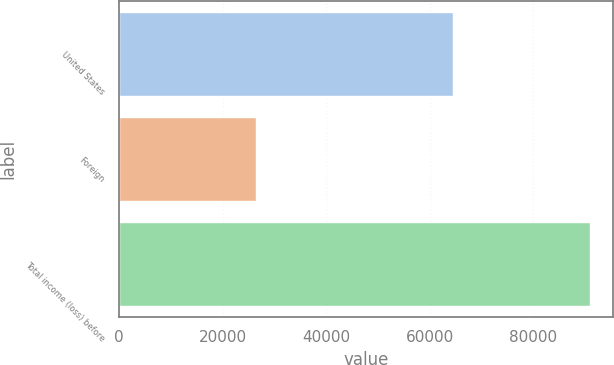Convert chart to OTSL. <chart><loc_0><loc_0><loc_500><loc_500><bar_chart><fcel>United States<fcel>Foreign<fcel>Total income (loss) before<nl><fcel>64424<fcel>26482<fcel>90906<nl></chart> 